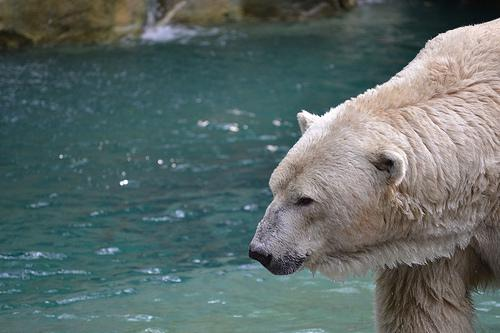Question: when will the animal drink water?
Choices:
A. When it is hungry.
B. When it is thirsty.
C. Tomorrow.
D. Next week.
Answer with the letter. Answer: B Question: what is the color of animal?
Choices:
A. Black.
B. White.
C. Green.
D. Red.
Answer with the letter. Answer: B Question: where is the picture taken?
Choices:
A. Near to water.
B. Downtown in the city.
C. In the mountains.
D. At the park.
Answer with the letter. Answer: A Question: who is in the picture?
Choices:
A. A man.
B. A bird.
C. Animal.
D. A woman.
Answer with the letter. Answer: C 